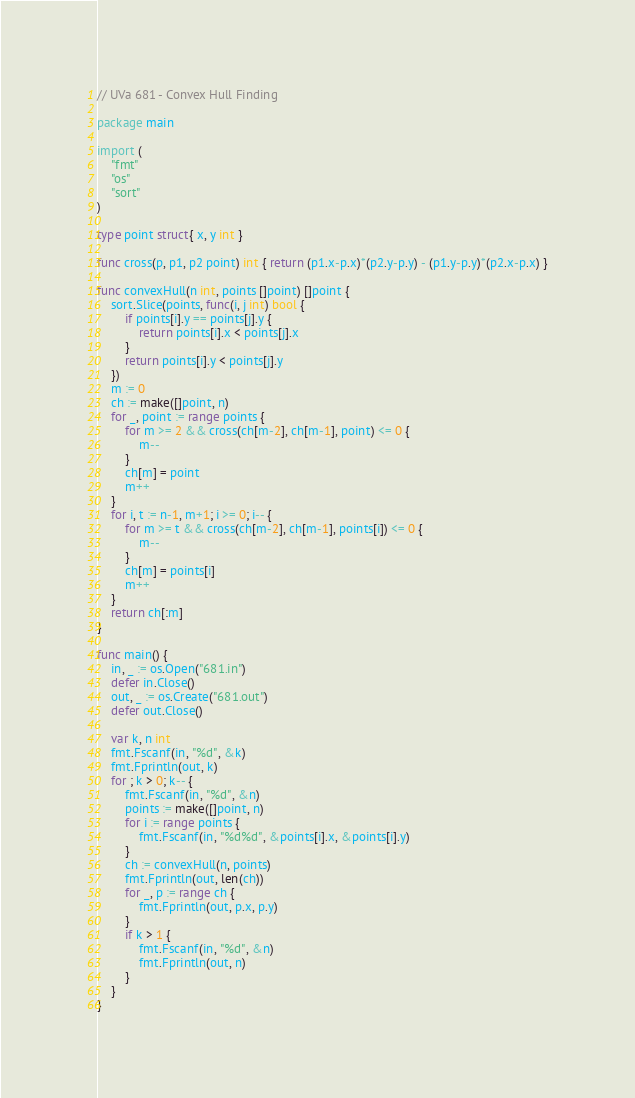<code> <loc_0><loc_0><loc_500><loc_500><_Go_>// UVa 681 - Convex Hull Finding

package main

import (
	"fmt"
	"os"
	"sort"
)

type point struct{ x, y int }

func cross(p, p1, p2 point) int { return (p1.x-p.x)*(p2.y-p.y) - (p1.y-p.y)*(p2.x-p.x) }

func convexHull(n int, points []point) []point {
	sort.Slice(points, func(i, j int) bool {
		if points[i].y == points[j].y {
			return points[i].x < points[j].x
		}
		return points[i].y < points[j].y
	})
	m := 0
	ch := make([]point, n)
	for _, point := range points {
		for m >= 2 && cross(ch[m-2], ch[m-1], point) <= 0 {
			m--
		}
		ch[m] = point
		m++
	}
	for i, t := n-1, m+1; i >= 0; i-- {
		for m >= t && cross(ch[m-2], ch[m-1], points[i]) <= 0 {
			m--
		}
		ch[m] = points[i]
		m++
	}
	return ch[:m]
}

func main() {
	in, _ := os.Open("681.in")
	defer in.Close()
	out, _ := os.Create("681.out")
	defer out.Close()

	var k, n int
	fmt.Fscanf(in, "%d", &k)
	fmt.Fprintln(out, k)
	for ; k > 0; k-- {
		fmt.Fscanf(in, "%d", &n)
		points := make([]point, n)
		for i := range points {
			fmt.Fscanf(in, "%d%d", &points[i].x, &points[i].y)
		}
		ch := convexHull(n, points)
		fmt.Fprintln(out, len(ch))
		for _, p := range ch {
			fmt.Fprintln(out, p.x, p.y)
		}
		if k > 1 {
			fmt.Fscanf(in, "%d", &n)
			fmt.Fprintln(out, n)
		}
	}
}
</code> 